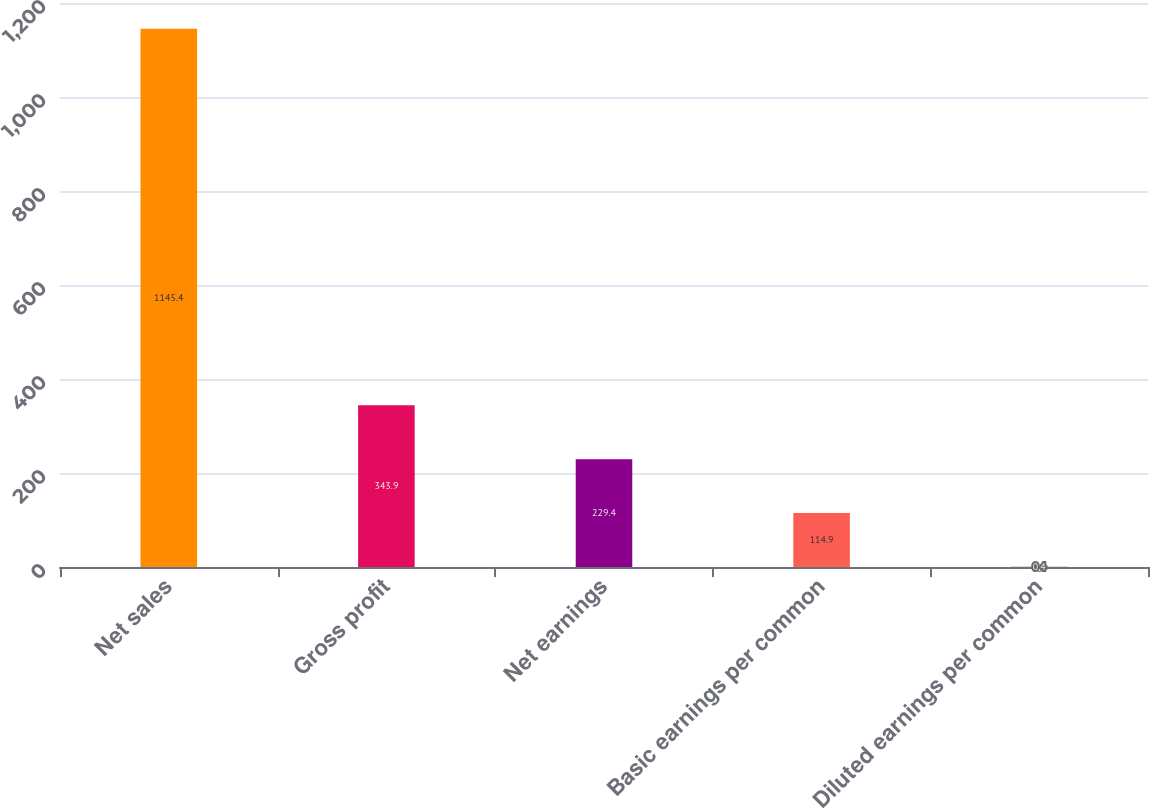Convert chart. <chart><loc_0><loc_0><loc_500><loc_500><bar_chart><fcel>Net sales<fcel>Gross profit<fcel>Net earnings<fcel>Basic earnings per common<fcel>Diluted earnings per common<nl><fcel>1145.4<fcel>343.9<fcel>229.4<fcel>114.9<fcel>0.4<nl></chart> 